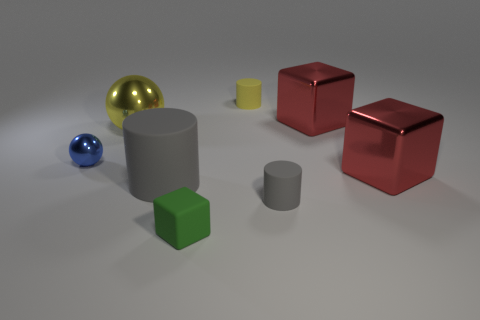What is the color of the other sphere that is made of the same material as the big yellow sphere?
Ensure brevity in your answer.  Blue. Are there any purple balls of the same size as the green cube?
Offer a terse response. No. Are there more large shiny balls right of the small ball than big yellow things in front of the small green block?
Ensure brevity in your answer.  Yes. Is the material of the tiny cylinder right of the yellow cylinder the same as the big cylinder right of the large yellow metal ball?
Offer a very short reply. Yes. What is the shape of the yellow object that is the same size as the blue sphere?
Provide a succinct answer. Cylinder. Are there any large red shiny things of the same shape as the tiny green matte thing?
Your response must be concise. Yes. Is the color of the big shiny thing that is to the left of the green rubber block the same as the matte block left of the small yellow object?
Give a very brief answer. No. Are there any large cylinders to the left of the large cylinder?
Your answer should be very brief. No. There is a large object that is both behind the big gray rubber cylinder and on the left side of the small matte block; what material is it made of?
Your answer should be very brief. Metal. Do the gray cylinder that is behind the tiny gray matte object and the tiny gray cylinder have the same material?
Your response must be concise. Yes. 